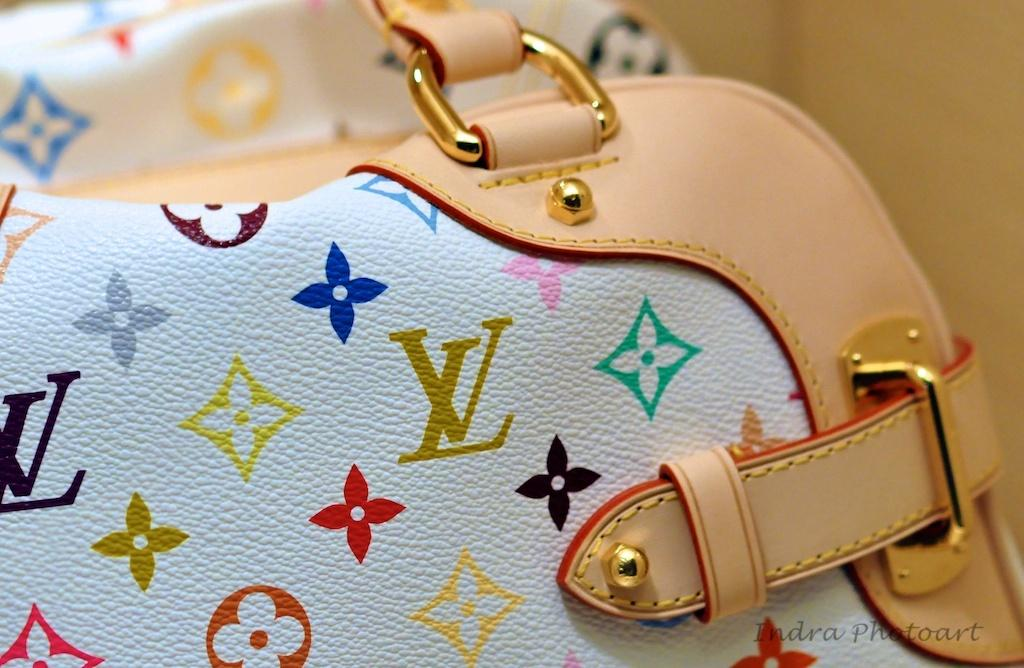What is the primary color of the bag in the image? The primary color of the bag in the image is white. Are there any additional materials or colors on the bag? Yes, there is pink leather stitched to the white bag. What can be seen in the background of the image? There is a wall in the background of the image. What type of rod can be seen in the image? There is no rod present in the image. How many trails are visible in the image? There are no trails visible in the image. 